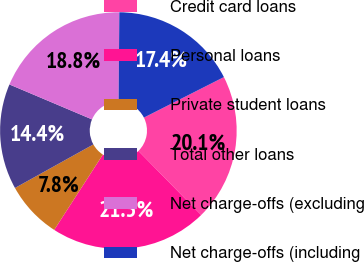Convert chart. <chart><loc_0><loc_0><loc_500><loc_500><pie_chart><fcel>Credit card loans<fcel>Personal loans<fcel>Private student loans<fcel>Total other loans<fcel>Net charge-offs (excluding<fcel>Net charge-offs (including<nl><fcel>20.12%<fcel>21.47%<fcel>7.8%<fcel>14.44%<fcel>18.76%<fcel>17.41%<nl></chart> 